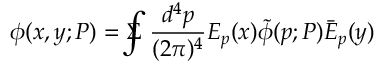Convert formula to latex. <formula><loc_0><loc_0><loc_500><loc_500>\phi ( x , y ; P ) = \Sigma \, \int \frac { d ^ { 4 } p } { ( 2 \pi ) ^ { 4 } } E _ { p } ( x ) \tilde { \phi } ( p ; P ) \bar { E } _ { p } ( y )</formula> 